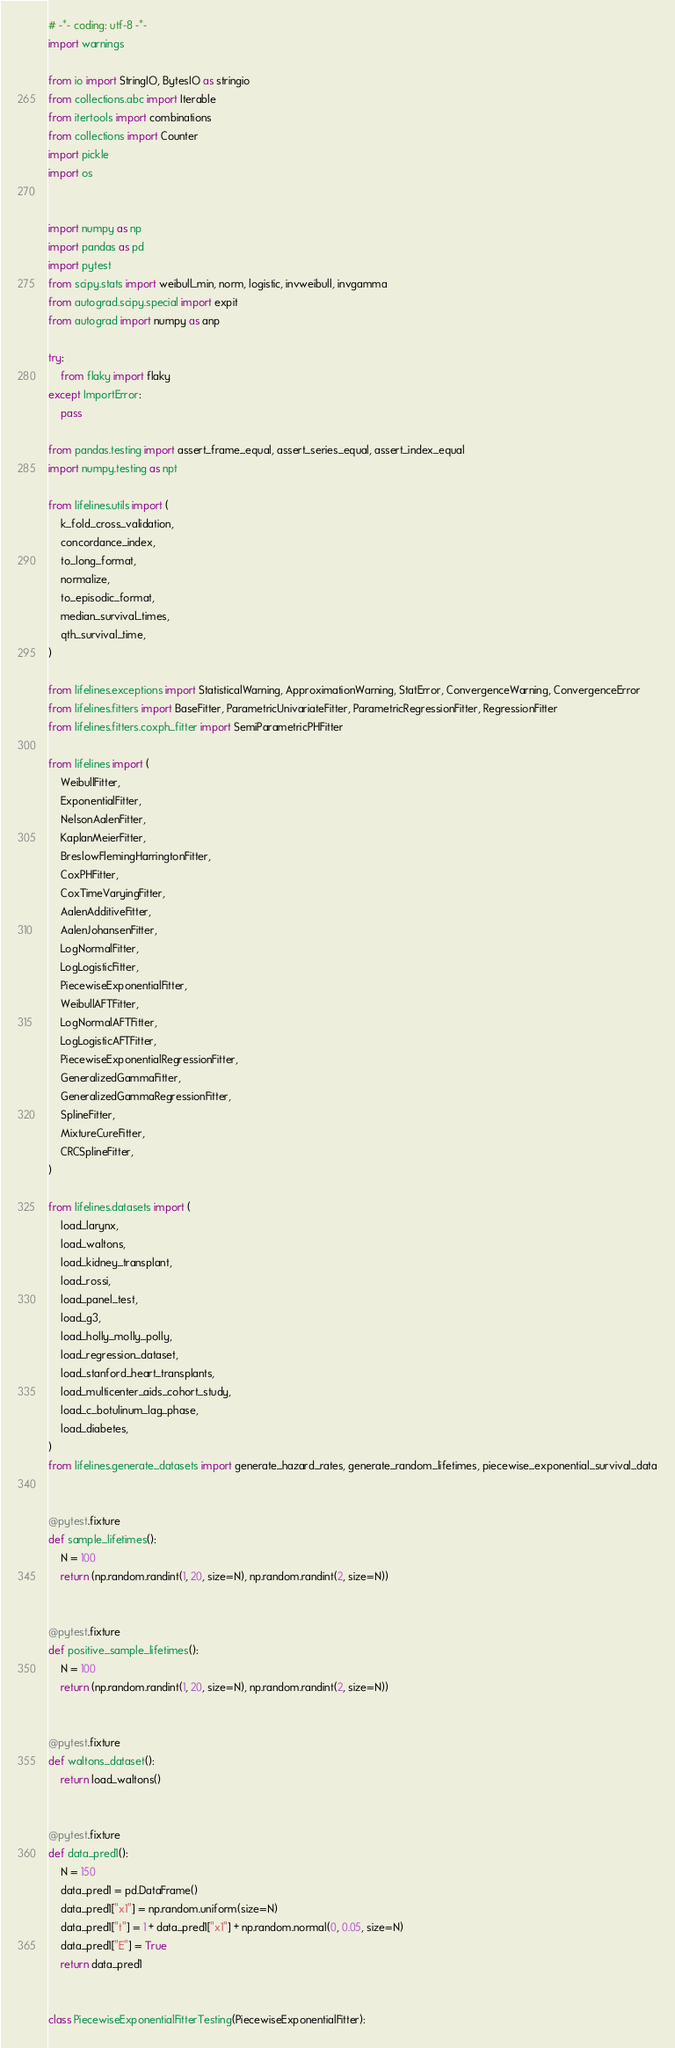Convert code to text. <code><loc_0><loc_0><loc_500><loc_500><_Python_># -*- coding: utf-8 -*-
import warnings

from io import StringIO, BytesIO as stringio
from collections.abc import Iterable
from itertools import combinations
from collections import Counter
import pickle
import os


import numpy as np
import pandas as pd
import pytest
from scipy.stats import weibull_min, norm, logistic, invweibull, invgamma
from autograd.scipy.special import expit
from autograd import numpy as anp

try:
    from flaky import flaky
except ImportError:
    pass

from pandas.testing import assert_frame_equal, assert_series_equal, assert_index_equal
import numpy.testing as npt

from lifelines.utils import (
    k_fold_cross_validation,
    concordance_index,
    to_long_format,
    normalize,
    to_episodic_format,
    median_survival_times,
    qth_survival_time,
)

from lifelines.exceptions import StatisticalWarning, ApproximationWarning, StatError, ConvergenceWarning, ConvergenceError
from lifelines.fitters import BaseFitter, ParametricUnivariateFitter, ParametricRegressionFitter, RegressionFitter
from lifelines.fitters.coxph_fitter import SemiParametricPHFitter

from lifelines import (
    WeibullFitter,
    ExponentialFitter,
    NelsonAalenFitter,
    KaplanMeierFitter,
    BreslowFlemingHarringtonFitter,
    CoxPHFitter,
    CoxTimeVaryingFitter,
    AalenAdditiveFitter,
    AalenJohansenFitter,
    LogNormalFitter,
    LogLogisticFitter,
    PiecewiseExponentialFitter,
    WeibullAFTFitter,
    LogNormalAFTFitter,
    LogLogisticAFTFitter,
    PiecewiseExponentialRegressionFitter,
    GeneralizedGammaFitter,
    GeneralizedGammaRegressionFitter,
    SplineFitter,
    MixtureCureFitter,
    CRCSplineFitter,
)

from lifelines.datasets import (
    load_larynx,
    load_waltons,
    load_kidney_transplant,
    load_rossi,
    load_panel_test,
    load_g3,
    load_holly_molly_polly,
    load_regression_dataset,
    load_stanford_heart_transplants,
    load_multicenter_aids_cohort_study,
    load_c_botulinum_lag_phase,
    load_diabetes,
)
from lifelines.generate_datasets import generate_hazard_rates, generate_random_lifetimes, piecewise_exponential_survival_data


@pytest.fixture
def sample_lifetimes():
    N = 100
    return (np.random.randint(1, 20, size=N), np.random.randint(2, size=N))


@pytest.fixture
def positive_sample_lifetimes():
    N = 100
    return (np.random.randint(1, 20, size=N), np.random.randint(2, size=N))


@pytest.fixture
def waltons_dataset():
    return load_waltons()


@pytest.fixture
def data_pred1():
    N = 150
    data_pred1 = pd.DataFrame()
    data_pred1["x1"] = np.random.uniform(size=N)
    data_pred1["t"] = 1 + data_pred1["x1"] + np.random.normal(0, 0.05, size=N)
    data_pred1["E"] = True
    return data_pred1


class PiecewiseExponentialFitterTesting(PiecewiseExponentialFitter):</code> 